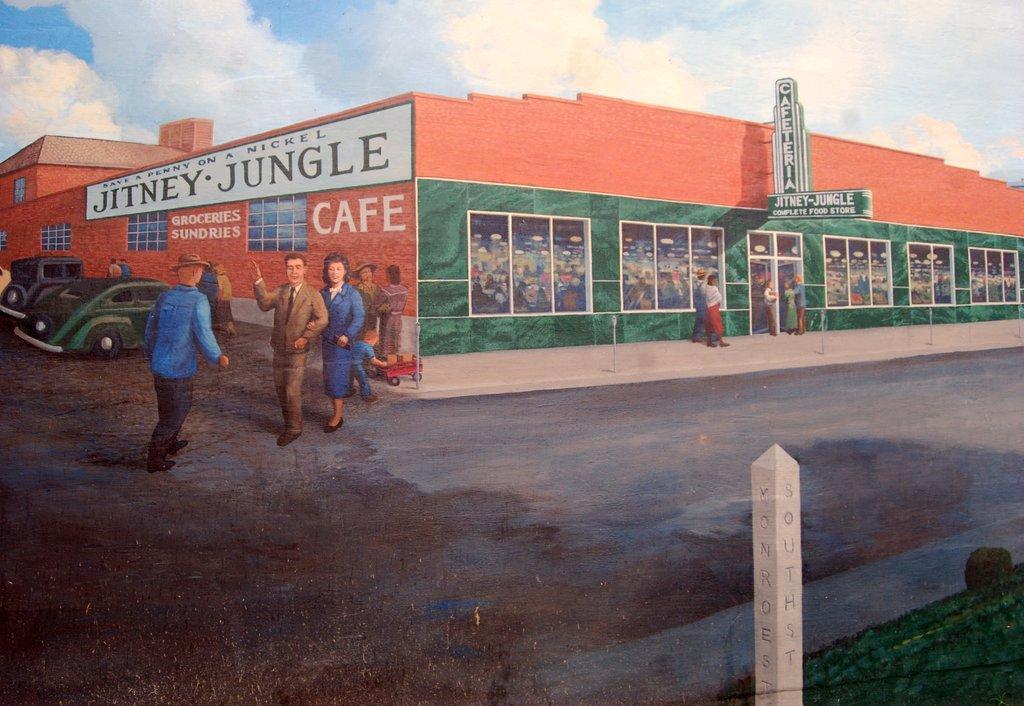Describe this image in one or two sentences. In this image I can see a poster with some people and a building with some text written on it. I can see the clouds in the sky. 